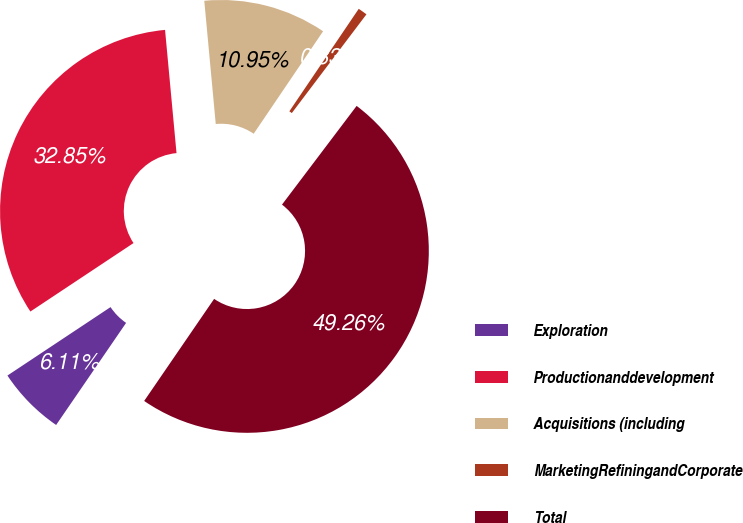Convert chart. <chart><loc_0><loc_0><loc_500><loc_500><pie_chart><fcel>Exploration<fcel>Productionanddevelopment<fcel>Acquisitions (including<fcel>MarketingRefiningandCorporate<fcel>Total<nl><fcel>6.11%<fcel>32.85%<fcel>10.95%<fcel>0.83%<fcel>49.26%<nl></chart> 